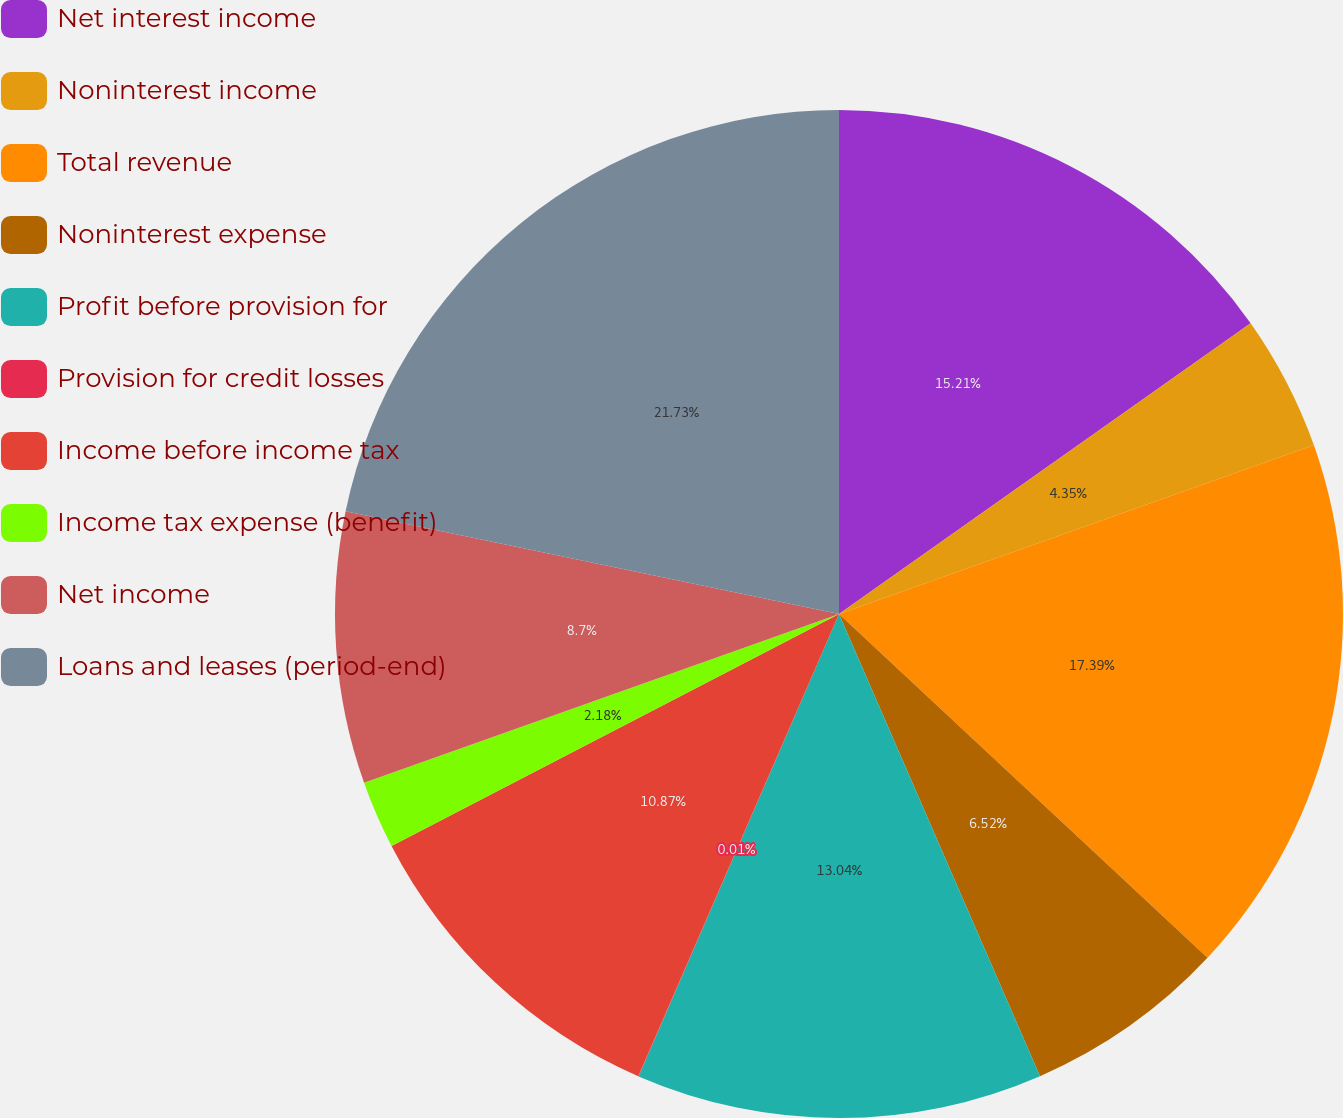Convert chart. <chart><loc_0><loc_0><loc_500><loc_500><pie_chart><fcel>Net interest income<fcel>Noninterest income<fcel>Total revenue<fcel>Noninterest expense<fcel>Profit before provision for<fcel>Provision for credit losses<fcel>Income before income tax<fcel>Income tax expense (benefit)<fcel>Net income<fcel>Loans and leases (period-end)<nl><fcel>15.21%<fcel>4.35%<fcel>17.39%<fcel>6.52%<fcel>13.04%<fcel>0.01%<fcel>10.87%<fcel>2.18%<fcel>8.7%<fcel>21.73%<nl></chart> 